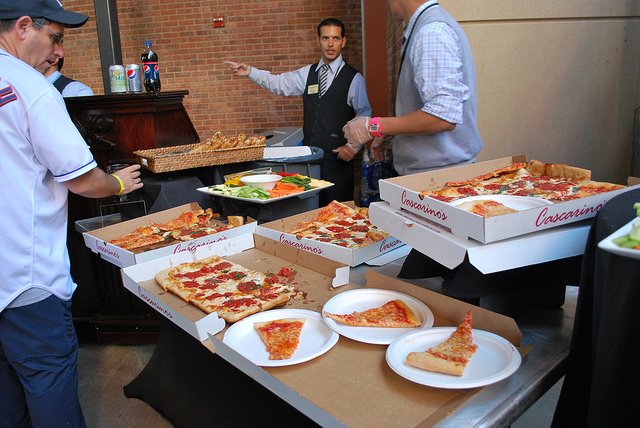Extract all visible text content from this image. Cascarino's Cason Casarino 